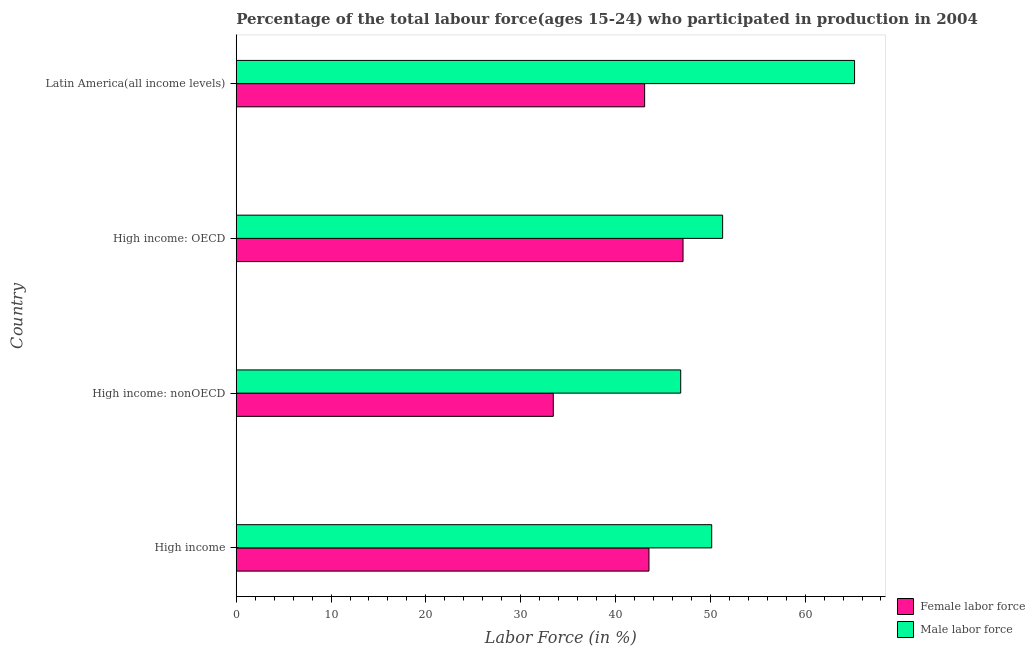Are the number of bars per tick equal to the number of legend labels?
Provide a succinct answer. Yes. How many bars are there on the 1st tick from the top?
Your answer should be very brief. 2. What is the label of the 4th group of bars from the top?
Your answer should be compact. High income. What is the percentage of male labour force in High income: nonOECD?
Your answer should be compact. 46.88. Across all countries, what is the maximum percentage of male labour force?
Your answer should be compact. 65.22. Across all countries, what is the minimum percentage of male labour force?
Provide a short and direct response. 46.88. In which country was the percentage of female labor force maximum?
Your response must be concise. High income: OECD. In which country was the percentage of female labor force minimum?
Keep it short and to the point. High income: nonOECD. What is the total percentage of female labor force in the graph?
Keep it short and to the point. 167.17. What is the difference between the percentage of female labor force in High income and that in Latin America(all income levels)?
Provide a short and direct response. 0.46. What is the difference between the percentage of female labor force in High income and the percentage of male labour force in High income: OECD?
Provide a short and direct response. -7.77. What is the average percentage of male labour force per country?
Your answer should be very brief. 53.38. What is the difference between the percentage of male labour force and percentage of female labor force in High income: OECD?
Ensure brevity in your answer.  4.17. In how many countries, is the percentage of female labor force greater than 14 %?
Keep it short and to the point. 4. Is the difference between the percentage of male labour force in High income and Latin America(all income levels) greater than the difference between the percentage of female labor force in High income and Latin America(all income levels)?
Make the answer very short. No. What is the difference between the highest and the second highest percentage of male labour force?
Offer a terse response. 13.92. What is the difference between the highest and the lowest percentage of male labour force?
Offer a terse response. 18.34. Is the sum of the percentage of male labour force in High income: OECD and High income: nonOECD greater than the maximum percentage of female labor force across all countries?
Make the answer very short. Yes. What does the 2nd bar from the top in High income: OECD represents?
Ensure brevity in your answer.  Female labor force. What does the 1st bar from the bottom in High income represents?
Your answer should be very brief. Female labor force. Are all the bars in the graph horizontal?
Make the answer very short. Yes. Are the values on the major ticks of X-axis written in scientific E-notation?
Offer a terse response. No. Does the graph contain grids?
Provide a succinct answer. No. What is the title of the graph?
Offer a terse response. Percentage of the total labour force(ages 15-24) who participated in production in 2004. Does "Transport services" appear as one of the legend labels in the graph?
Offer a terse response. No. What is the Labor Force (in %) of Female labor force in High income?
Offer a terse response. 43.53. What is the Labor Force (in %) in Male labor force in High income?
Ensure brevity in your answer.  50.15. What is the Labor Force (in %) in Female labor force in High income: nonOECD?
Provide a short and direct response. 33.44. What is the Labor Force (in %) in Male labor force in High income: nonOECD?
Offer a very short reply. 46.88. What is the Labor Force (in %) in Female labor force in High income: OECD?
Your response must be concise. 47.12. What is the Labor Force (in %) in Male labor force in High income: OECD?
Provide a succinct answer. 51.3. What is the Labor Force (in %) in Female labor force in Latin America(all income levels)?
Make the answer very short. 43.07. What is the Labor Force (in %) in Male labor force in Latin America(all income levels)?
Your response must be concise. 65.22. Across all countries, what is the maximum Labor Force (in %) of Female labor force?
Provide a succinct answer. 47.12. Across all countries, what is the maximum Labor Force (in %) of Male labor force?
Ensure brevity in your answer.  65.22. Across all countries, what is the minimum Labor Force (in %) of Female labor force?
Offer a terse response. 33.44. Across all countries, what is the minimum Labor Force (in %) in Male labor force?
Your answer should be compact. 46.88. What is the total Labor Force (in %) of Female labor force in the graph?
Your answer should be compact. 167.17. What is the total Labor Force (in %) in Male labor force in the graph?
Keep it short and to the point. 213.54. What is the difference between the Labor Force (in %) of Female labor force in High income and that in High income: nonOECD?
Keep it short and to the point. 10.09. What is the difference between the Labor Force (in %) of Male labor force in High income and that in High income: nonOECD?
Give a very brief answer. 3.27. What is the difference between the Labor Force (in %) of Female labor force in High income and that in High income: OECD?
Offer a very short reply. -3.59. What is the difference between the Labor Force (in %) of Male labor force in High income and that in High income: OECD?
Ensure brevity in your answer.  -1.15. What is the difference between the Labor Force (in %) of Female labor force in High income and that in Latin America(all income levels)?
Make the answer very short. 0.46. What is the difference between the Labor Force (in %) of Male labor force in High income and that in Latin America(all income levels)?
Give a very brief answer. -15.07. What is the difference between the Labor Force (in %) in Female labor force in High income: nonOECD and that in High income: OECD?
Your answer should be compact. -13.68. What is the difference between the Labor Force (in %) in Male labor force in High income: nonOECD and that in High income: OECD?
Offer a very short reply. -4.42. What is the difference between the Labor Force (in %) in Female labor force in High income: nonOECD and that in Latin America(all income levels)?
Offer a very short reply. -9.63. What is the difference between the Labor Force (in %) in Male labor force in High income: nonOECD and that in Latin America(all income levels)?
Your answer should be compact. -18.34. What is the difference between the Labor Force (in %) in Female labor force in High income: OECD and that in Latin America(all income levels)?
Provide a succinct answer. 4.05. What is the difference between the Labor Force (in %) of Male labor force in High income: OECD and that in Latin America(all income levels)?
Your response must be concise. -13.92. What is the difference between the Labor Force (in %) of Female labor force in High income and the Labor Force (in %) of Male labor force in High income: nonOECD?
Your answer should be compact. -3.35. What is the difference between the Labor Force (in %) in Female labor force in High income and the Labor Force (in %) in Male labor force in High income: OECD?
Make the answer very short. -7.77. What is the difference between the Labor Force (in %) of Female labor force in High income and the Labor Force (in %) of Male labor force in Latin America(all income levels)?
Offer a very short reply. -21.68. What is the difference between the Labor Force (in %) in Female labor force in High income: nonOECD and the Labor Force (in %) in Male labor force in High income: OECD?
Ensure brevity in your answer.  -17.86. What is the difference between the Labor Force (in %) of Female labor force in High income: nonOECD and the Labor Force (in %) of Male labor force in Latin America(all income levels)?
Your answer should be very brief. -31.77. What is the difference between the Labor Force (in %) of Female labor force in High income: OECD and the Labor Force (in %) of Male labor force in Latin America(all income levels)?
Make the answer very short. -18.09. What is the average Labor Force (in %) of Female labor force per country?
Offer a terse response. 41.79. What is the average Labor Force (in %) in Male labor force per country?
Provide a short and direct response. 53.38. What is the difference between the Labor Force (in %) in Female labor force and Labor Force (in %) in Male labor force in High income?
Provide a succinct answer. -6.62. What is the difference between the Labor Force (in %) of Female labor force and Labor Force (in %) of Male labor force in High income: nonOECD?
Ensure brevity in your answer.  -13.44. What is the difference between the Labor Force (in %) of Female labor force and Labor Force (in %) of Male labor force in High income: OECD?
Your answer should be compact. -4.17. What is the difference between the Labor Force (in %) in Female labor force and Labor Force (in %) in Male labor force in Latin America(all income levels)?
Offer a very short reply. -22.14. What is the ratio of the Labor Force (in %) of Female labor force in High income to that in High income: nonOECD?
Provide a short and direct response. 1.3. What is the ratio of the Labor Force (in %) of Male labor force in High income to that in High income: nonOECD?
Your answer should be very brief. 1.07. What is the ratio of the Labor Force (in %) of Female labor force in High income to that in High income: OECD?
Your response must be concise. 0.92. What is the ratio of the Labor Force (in %) in Male labor force in High income to that in High income: OECD?
Keep it short and to the point. 0.98. What is the ratio of the Labor Force (in %) of Female labor force in High income to that in Latin America(all income levels)?
Provide a short and direct response. 1.01. What is the ratio of the Labor Force (in %) in Male labor force in High income to that in Latin America(all income levels)?
Keep it short and to the point. 0.77. What is the ratio of the Labor Force (in %) of Female labor force in High income: nonOECD to that in High income: OECD?
Your answer should be compact. 0.71. What is the ratio of the Labor Force (in %) in Male labor force in High income: nonOECD to that in High income: OECD?
Provide a succinct answer. 0.91. What is the ratio of the Labor Force (in %) in Female labor force in High income: nonOECD to that in Latin America(all income levels)?
Offer a very short reply. 0.78. What is the ratio of the Labor Force (in %) of Male labor force in High income: nonOECD to that in Latin America(all income levels)?
Your answer should be very brief. 0.72. What is the ratio of the Labor Force (in %) of Female labor force in High income: OECD to that in Latin America(all income levels)?
Keep it short and to the point. 1.09. What is the ratio of the Labor Force (in %) in Male labor force in High income: OECD to that in Latin America(all income levels)?
Your answer should be very brief. 0.79. What is the difference between the highest and the second highest Labor Force (in %) of Female labor force?
Keep it short and to the point. 3.59. What is the difference between the highest and the second highest Labor Force (in %) of Male labor force?
Offer a very short reply. 13.92. What is the difference between the highest and the lowest Labor Force (in %) of Female labor force?
Your answer should be compact. 13.68. What is the difference between the highest and the lowest Labor Force (in %) in Male labor force?
Offer a terse response. 18.34. 